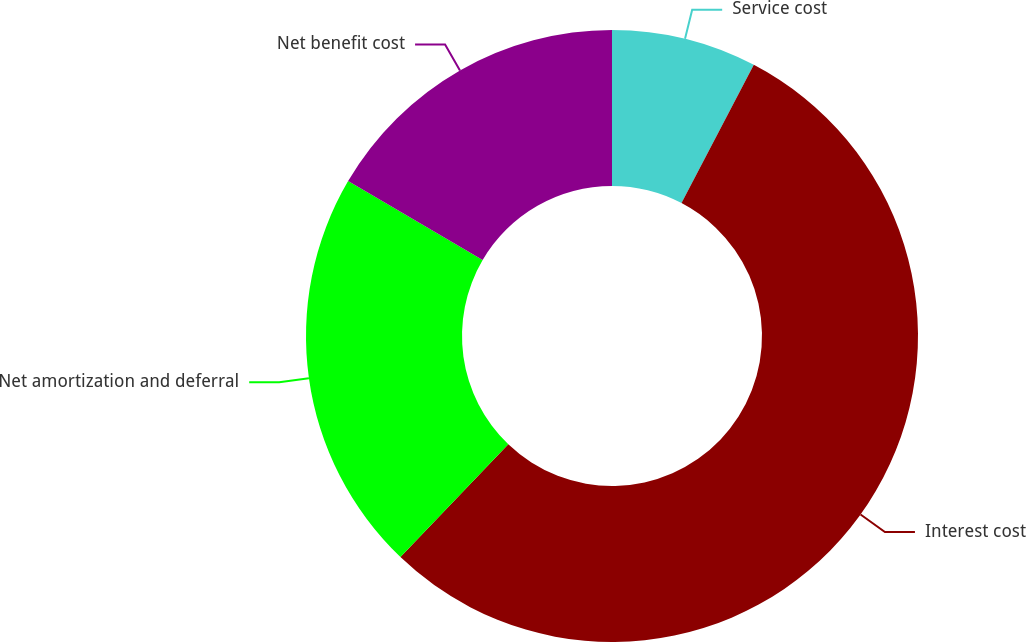Convert chart. <chart><loc_0><loc_0><loc_500><loc_500><pie_chart><fcel>Service cost<fcel>Interest cost<fcel>Net amortization and deferral<fcel>Net benefit cost<nl><fcel>7.67%<fcel>54.48%<fcel>21.3%<fcel>16.55%<nl></chart> 